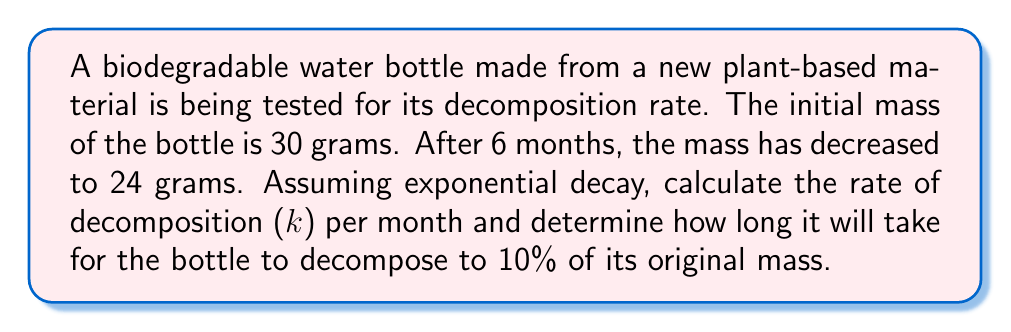Give your solution to this math problem. 1) The exponential decay formula is:
   $$ A(t) = A_0 e^{-kt} $$
   where $A(t)$ is the amount at time $t$, $A_0$ is the initial amount, $k$ is the decay rate, and $t$ is time.

2) We know:
   $A_0 = 30$ grams
   $A(6) = 24$ grams
   $t = 6$ months

3) Plug these values into the formula:
   $$ 24 = 30 e^{-6k} $$

4) Divide both sides by 30:
   $$ \frac{24}{30} = e^{-6k} $$

5) Take the natural log of both sides:
   $$ \ln(\frac{4}{5}) = -6k $$

6) Solve for $k$:
   $$ k = -\frac{1}{6}\ln(\frac{4}{5}) \approx 0.0365 $$ per month

7) To find the time when 10% of the original mass remains:
   $$ 0.1 \cdot 30 = 30 e^{-kt} $$

8) Simplify:
   $$ 0.1 = e^{-kt} $$

9) Take the natural log of both sides:
   $$ \ln(0.1) = -kt $$

10) Solve for $t$:
    $$ t = -\frac{\ln(0.1)}{k} \approx 63.1 $$ months
Answer: $k \approx 0.0365$ per month; $t \approx 63.1$ months 